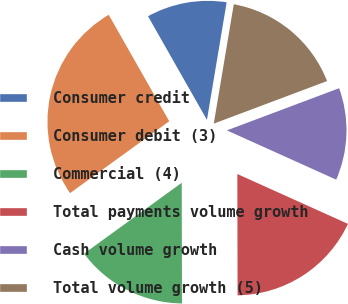<chart> <loc_0><loc_0><loc_500><loc_500><pie_chart><fcel>Consumer credit<fcel>Consumer debit (3)<fcel>Commercial (4)<fcel>Total payments volume growth<fcel>Cash volume growth<fcel>Total volume growth (5)<nl><fcel>10.87%<fcel>26.76%<fcel>15.05%<fcel>18.23%<fcel>12.46%<fcel>16.64%<nl></chart> 